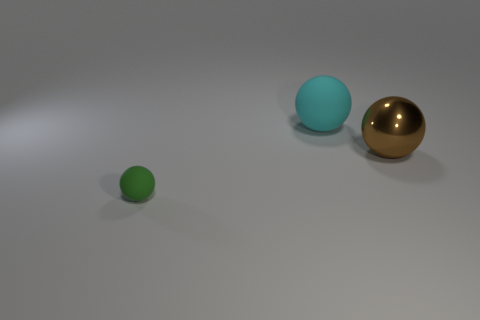The metal object that is the same size as the cyan rubber thing is what color?
Provide a short and direct response. Brown. What number of things are brown metal objects that are in front of the cyan ball or gray matte spheres?
Provide a short and direct response. 1. How many other objects are the same size as the cyan sphere?
Offer a very short reply. 1. What size is the matte object that is in front of the metallic thing?
Your answer should be very brief. Small. What shape is the tiny green object that is the same material as the large cyan thing?
Provide a short and direct response. Sphere. Are there any other things that are the same color as the metal sphere?
Your response must be concise. No. What is the color of the rubber thing right of the thing in front of the brown object?
Provide a short and direct response. Cyan. What number of tiny things are either green things or brown metal balls?
Provide a succinct answer. 1. What material is the green object that is the same shape as the cyan rubber object?
Give a very brief answer. Rubber. Is there anything else that is made of the same material as the large brown thing?
Provide a succinct answer. No. 